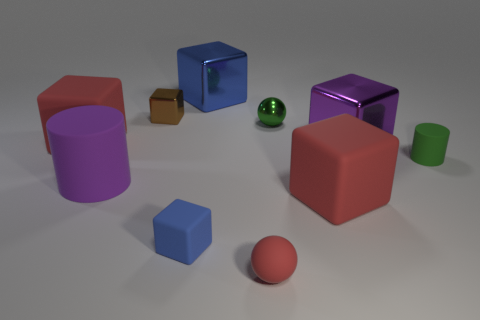Subtract 1 blocks. How many blocks are left? 5 Subtract all red blocks. How many blocks are left? 4 Subtract all small brown cubes. How many cubes are left? 5 Subtract all cyan blocks. Subtract all gray cylinders. How many blocks are left? 6 Subtract all cubes. How many objects are left? 4 Subtract 0 brown spheres. How many objects are left? 10 Subtract all blue matte cubes. Subtract all brown things. How many objects are left? 8 Add 2 brown blocks. How many brown blocks are left? 3 Add 9 big green matte spheres. How many big green matte spheres exist? 9 